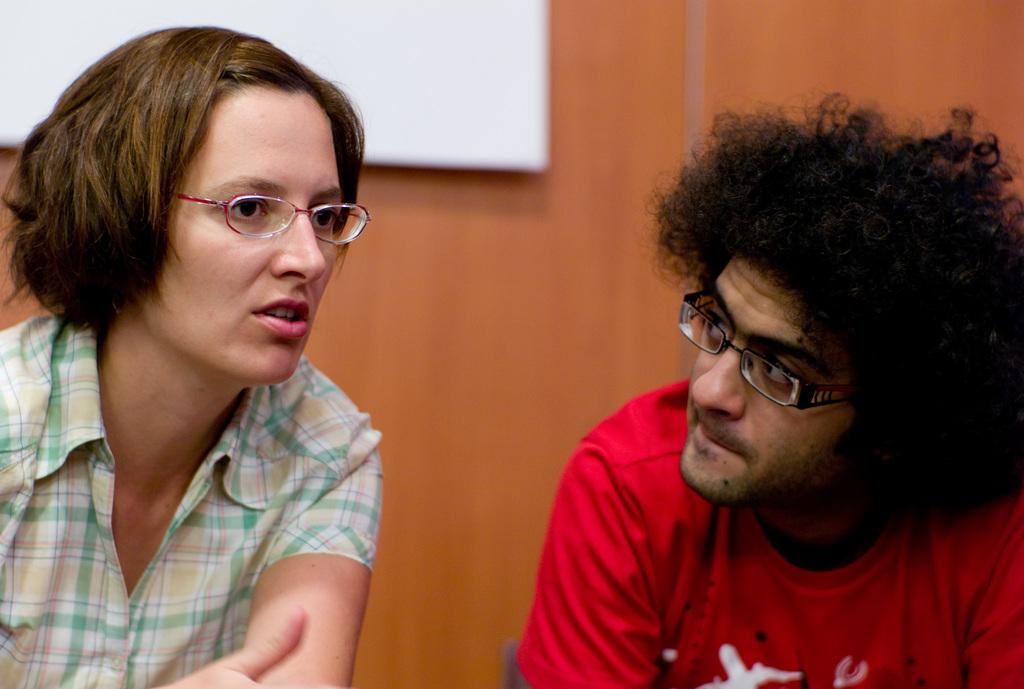How many people are in the image? There are two people in the image. What can be observed about the people's clothing? The people are wearing different color dresses. What color is the object in the image? There is a white color object in the image. What color is the wall in the image? There is a brown color wall in the image. Can you see any clouds in the image? There is no mention of clouds in the provided facts, and therefore we cannot determine if any are present in the image. 